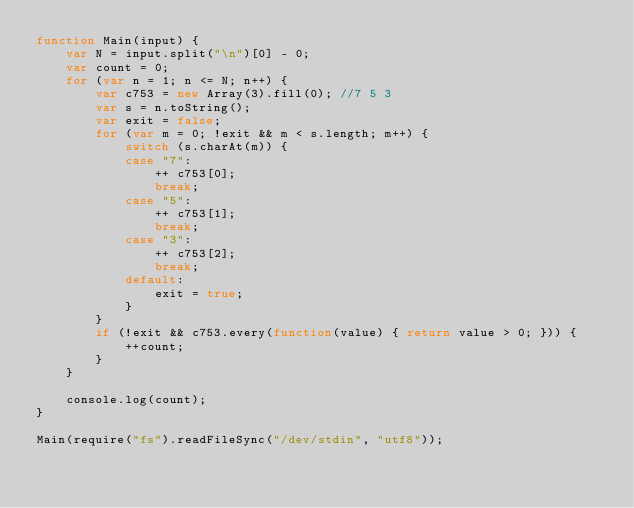<code> <loc_0><loc_0><loc_500><loc_500><_JavaScript_>function Main(input) {
    var N = input.split("\n")[0] - 0;
    var count = 0;
    for (var n = 1; n <= N; n++) {
        var c753 = new Array(3).fill(0); //7 5 3
        var s = n.toString();
        var exit = false;
        for (var m = 0; !exit && m < s.length; m++) {
            switch (s.charAt(m)) {
            case "7": 
                ++ c753[0];
                break;
            case "5":
                ++ c753[1];
                break;
            case "3":
                ++ c753[2];
                break;
            default:
                exit = true;
            }
        }
        if (!exit && c753.every(function(value) { return value > 0; })) {
            ++count;
        }
    }

    console.log(count);
}

Main(require("fs").readFileSync("/dev/stdin", "utf8"));
</code> 